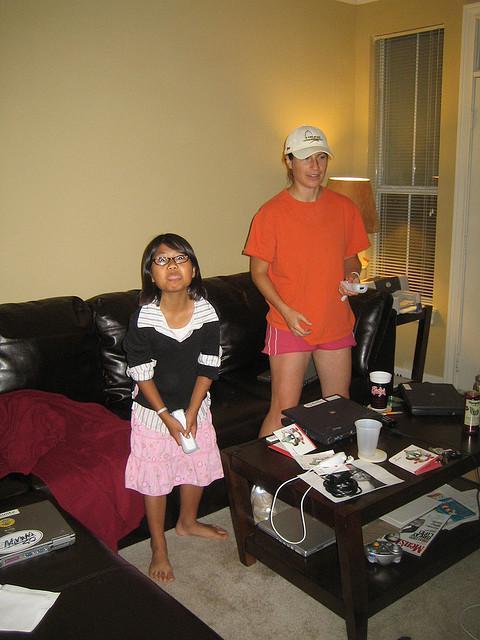How many cups are on the coffee table?
Give a very brief answer. 2. How many people are in the picture?
Give a very brief answer. 2. How many couches are there?
Give a very brief answer. 2. How many laptops can you see?
Give a very brief answer. 4. How many of the airplanes have entrails?
Give a very brief answer. 0. 